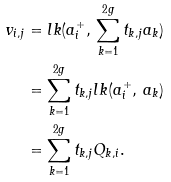<formula> <loc_0><loc_0><loc_500><loc_500>v _ { i , j } & = l k ( a _ { i } ^ { + } , \, \sum _ { k = 1 } ^ { 2 g } t _ { k , j } a _ { k } ) \\ & = \sum _ { k = 1 } ^ { 2 g } t _ { k , j } l k ( a _ { i } ^ { + } , \, a _ { k } ) \\ & = \sum _ { k = 1 } ^ { 2 g } t _ { k , j } Q _ { k , i } .</formula> 